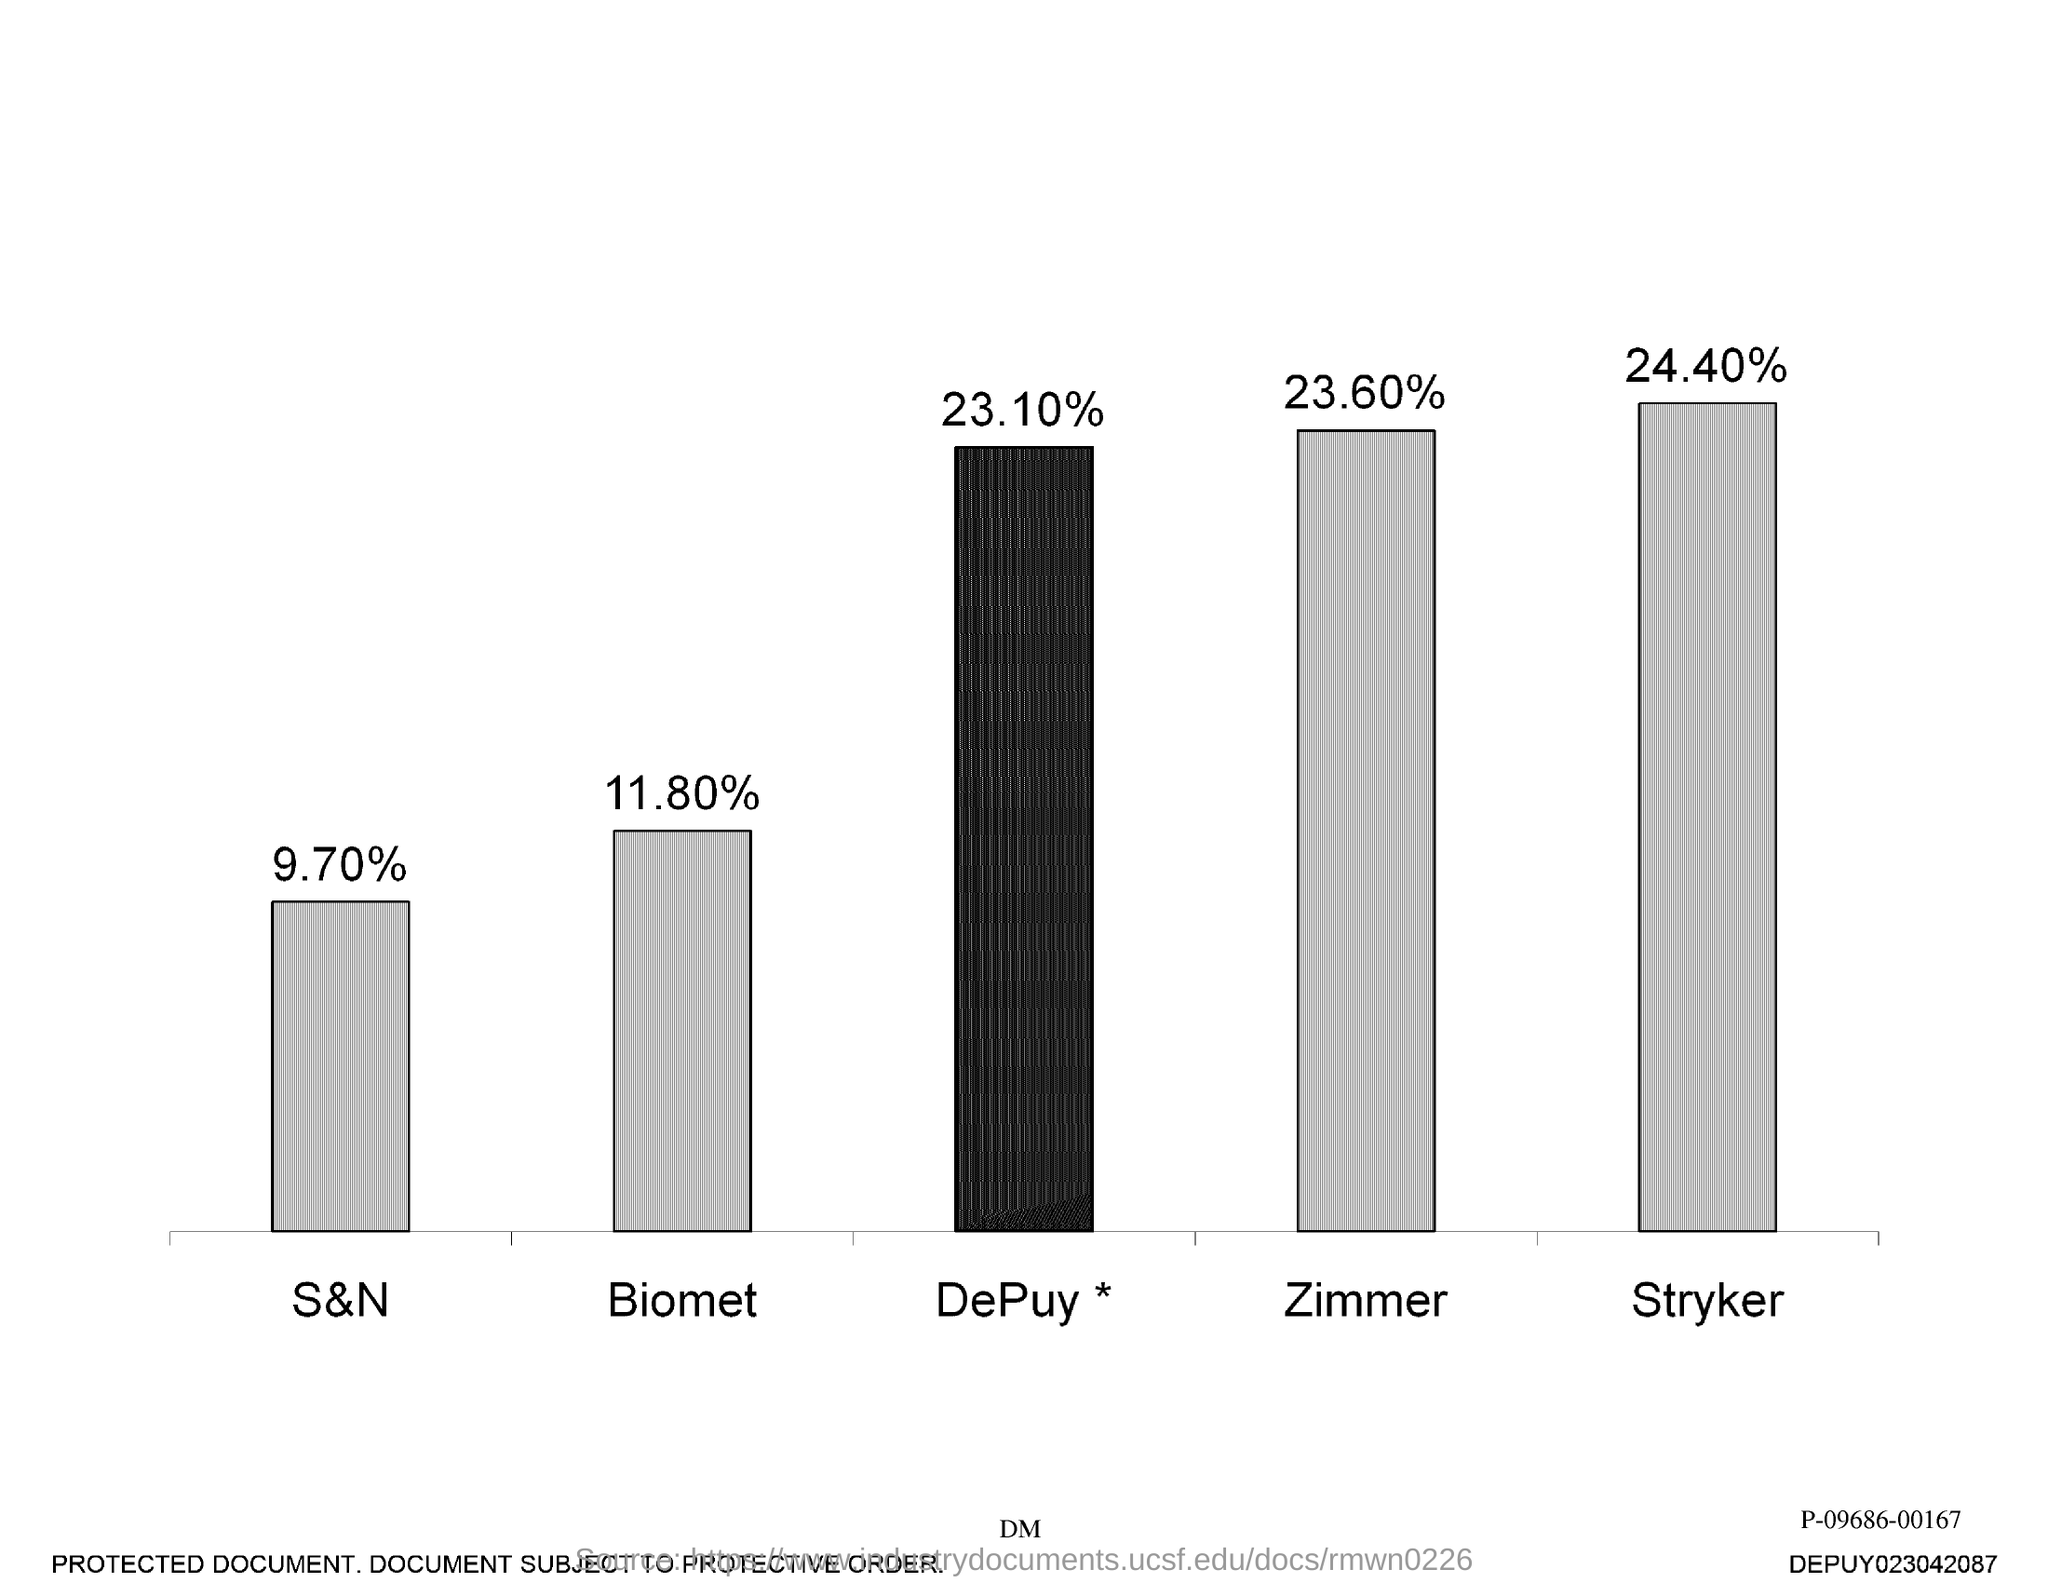What is the percentage of S & N?
Keep it short and to the point. 9.70. What is the percentage of Biomet?
Ensure brevity in your answer.  11.80. What is the percentage of Depuy?
Keep it short and to the point. 23.10%. What is the percentage of Zimmer?
Offer a very short reply. 23.60. What is the percentage of Stryker?
Keep it short and to the point. 24.40. The highest percentage is for which company?
Your answer should be very brief. Stryker. The lowest percentage is for which company?
Your answer should be very brief. S&N. 